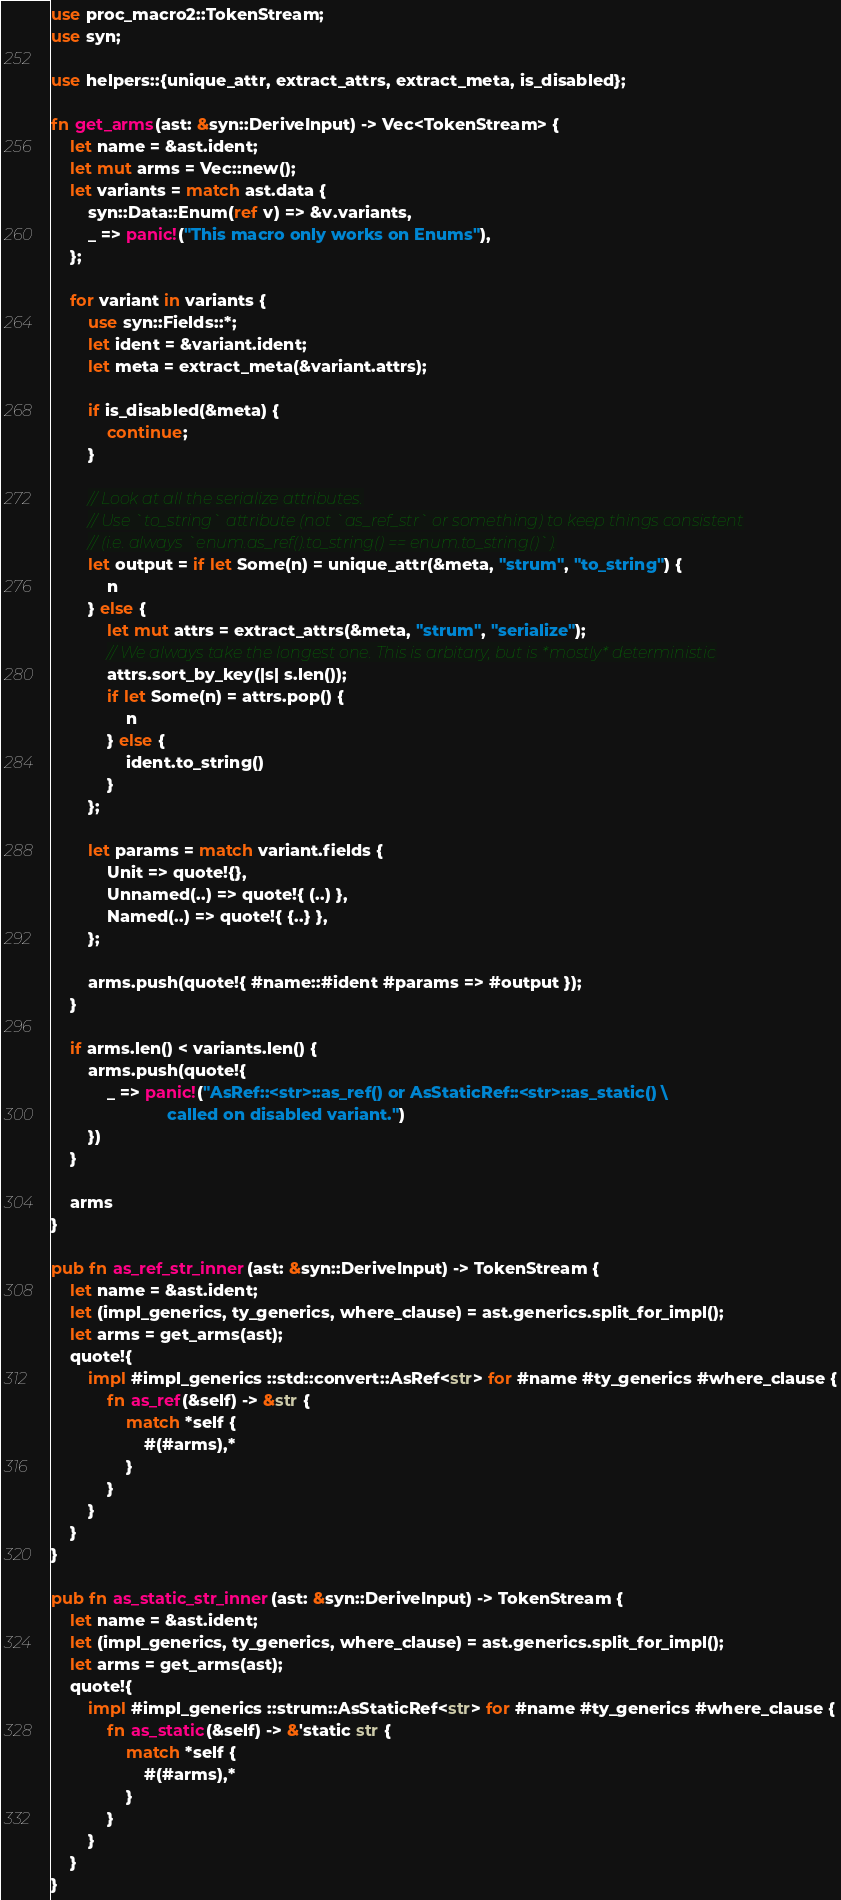Convert code to text. <code><loc_0><loc_0><loc_500><loc_500><_Rust_>use proc_macro2::TokenStream;
use syn;

use helpers::{unique_attr, extract_attrs, extract_meta, is_disabled};

fn get_arms(ast: &syn::DeriveInput) -> Vec<TokenStream> {
    let name = &ast.ident;
    let mut arms = Vec::new();
    let variants = match ast.data {
        syn::Data::Enum(ref v) => &v.variants,
        _ => panic!("This macro only works on Enums"),
    };

    for variant in variants {
        use syn::Fields::*;
        let ident = &variant.ident;
        let meta = extract_meta(&variant.attrs);

        if is_disabled(&meta) {
            continue;
        }

        // Look at all the serialize attributes.
        // Use `to_string` attribute (not `as_ref_str` or something) to keep things consistent
        // (i.e. always `enum.as_ref().to_string() == enum.to_string()`).
        let output = if let Some(n) = unique_attr(&meta, "strum", "to_string") {
            n
        } else {
            let mut attrs = extract_attrs(&meta, "strum", "serialize");
            // We always take the longest one. This is arbitary, but is *mostly* deterministic
            attrs.sort_by_key(|s| s.len());
            if let Some(n) = attrs.pop() {
                n
            } else {
                ident.to_string()
            }
        };

        let params = match variant.fields {
            Unit => quote!{},
            Unnamed(..) => quote!{ (..) },
            Named(..) => quote!{ {..} },
        };

        arms.push(quote!{ #name::#ident #params => #output });
    }

    if arms.len() < variants.len() {
        arms.push(quote!{
            _ => panic!("AsRef::<str>::as_ref() or AsStaticRef::<str>::as_static() \
                         called on disabled variant.")
        })
    }

    arms
}

pub fn as_ref_str_inner(ast: &syn::DeriveInput) -> TokenStream {
    let name = &ast.ident;
    let (impl_generics, ty_generics, where_clause) = ast.generics.split_for_impl();
    let arms = get_arms(ast);
    quote!{
        impl #impl_generics ::std::convert::AsRef<str> for #name #ty_generics #where_clause {
            fn as_ref(&self) -> &str {
                match *self {
                    #(#arms),*
                }
            }
        }
    }
}

pub fn as_static_str_inner(ast: &syn::DeriveInput) -> TokenStream {
    let name = &ast.ident;
    let (impl_generics, ty_generics, where_clause) = ast.generics.split_for_impl();
    let arms = get_arms(ast);
    quote!{
        impl #impl_generics ::strum::AsStaticRef<str> for #name #ty_generics #where_clause {
            fn as_static(&self) -> &'static str {
                match *self {
                    #(#arms),*
                }
            }
        }
    }
}
</code> 